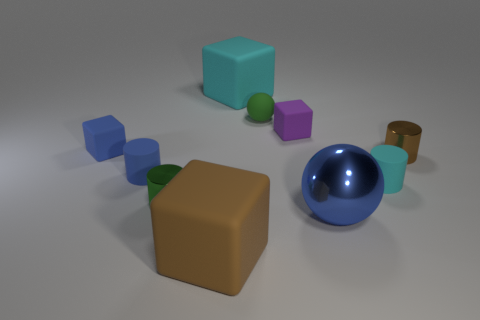Subtract all spheres. How many objects are left? 8 Add 7 purple rubber balls. How many purple rubber balls exist? 7 Subtract 1 brown cylinders. How many objects are left? 9 Subtract all red metallic spheres. Subtract all blue shiny objects. How many objects are left? 9 Add 4 cyan cylinders. How many cyan cylinders are left? 5 